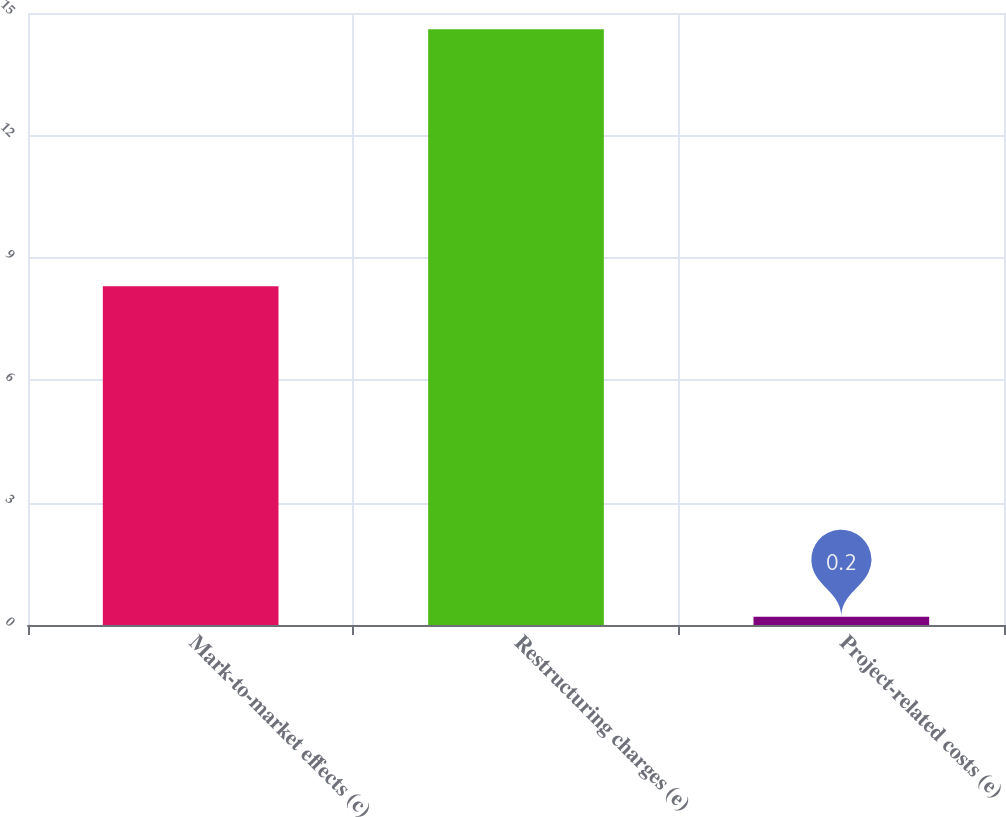Convert chart to OTSL. <chart><loc_0><loc_0><loc_500><loc_500><bar_chart><fcel>Mark-to-market effects (c)<fcel>Restructuring charges (e)<fcel>Project-related costs (e)<nl><fcel>8.3<fcel>14.6<fcel>0.2<nl></chart> 